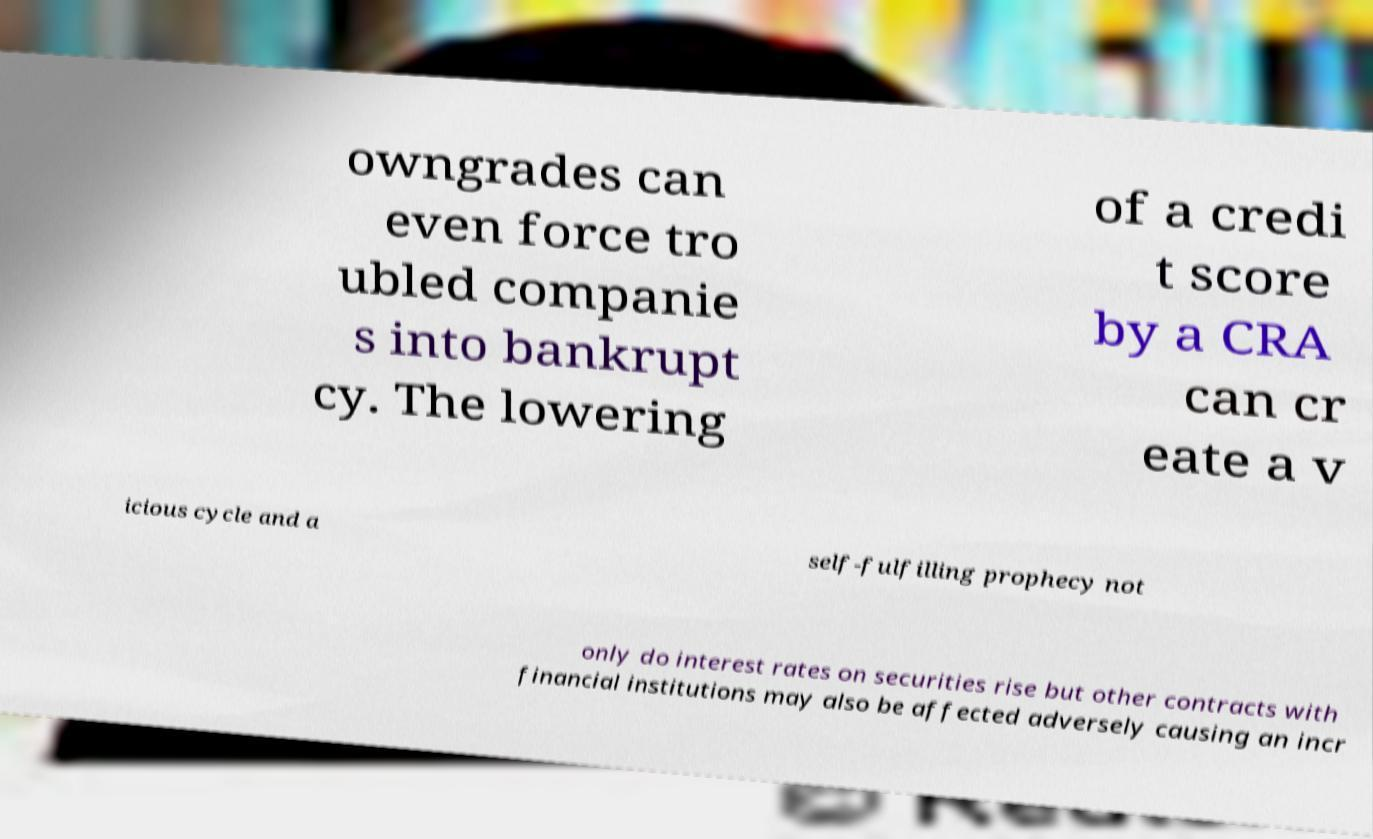Can you read and provide the text displayed in the image?This photo seems to have some interesting text. Can you extract and type it out for me? owngrades can even force tro ubled companie s into bankrupt cy. The lowering of a credi t score by a CRA can cr eate a v icious cycle and a self-fulfilling prophecy not only do interest rates on securities rise but other contracts with financial institutions may also be affected adversely causing an incr 